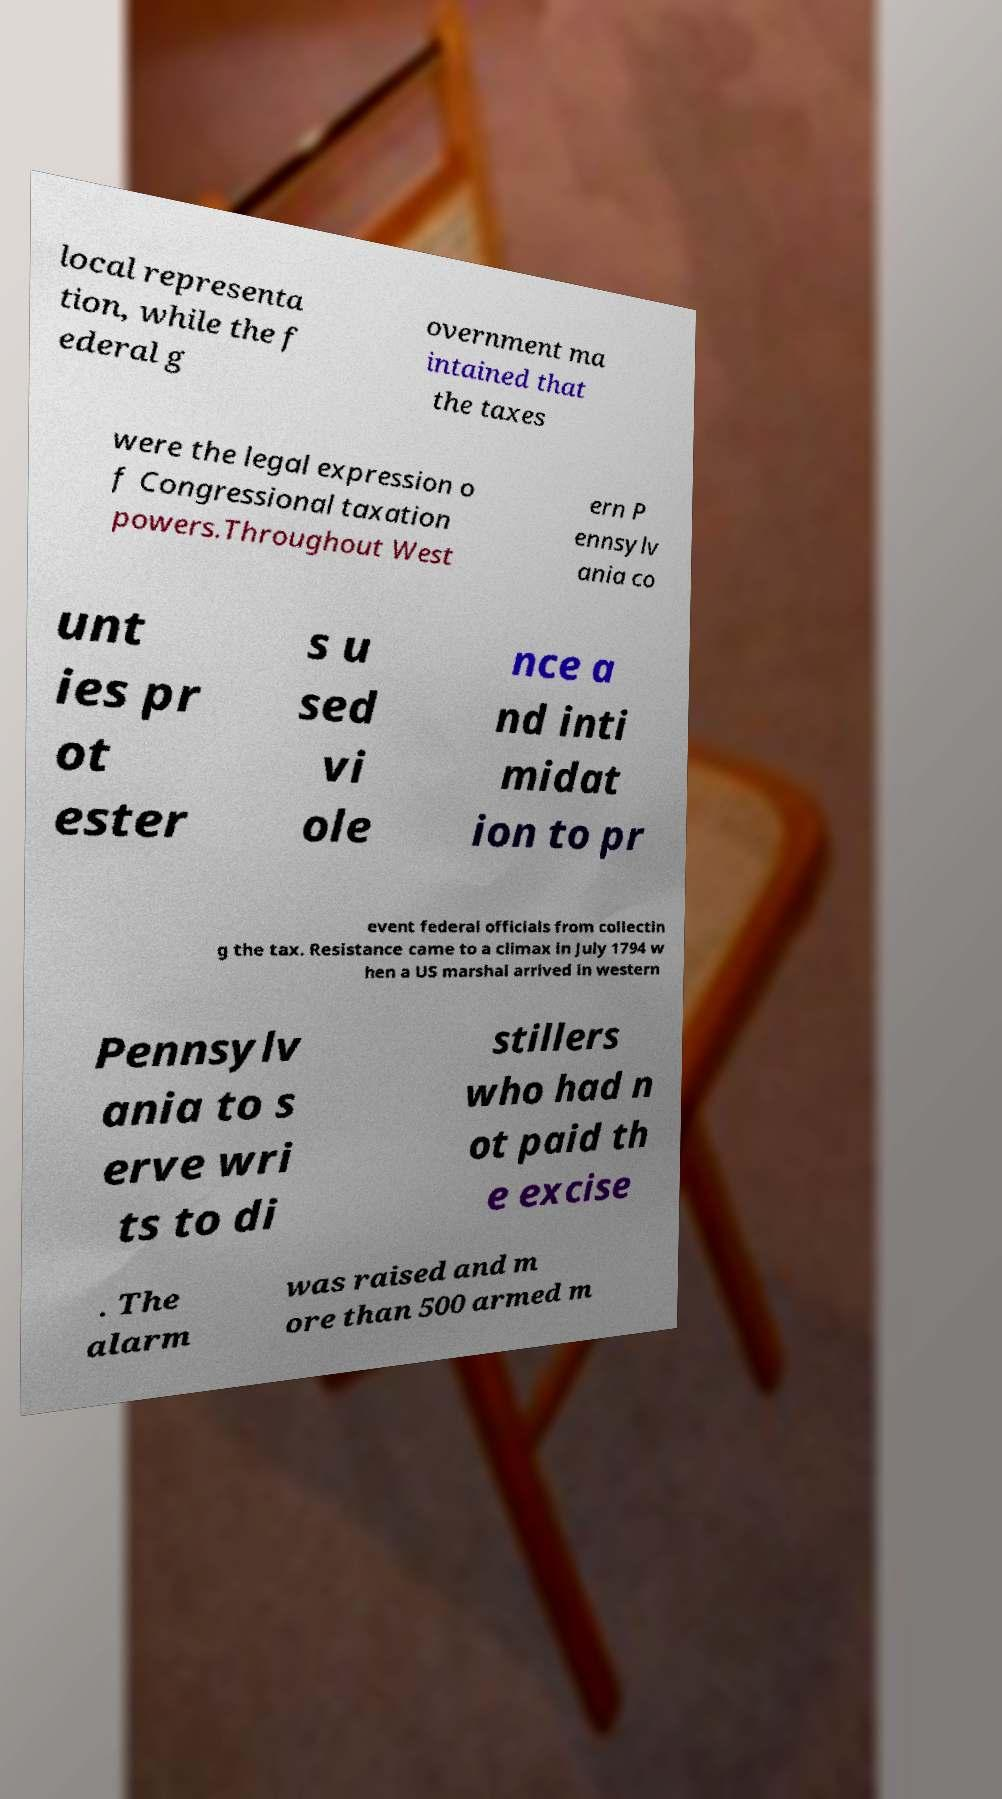For documentation purposes, I need the text within this image transcribed. Could you provide that? local representa tion, while the f ederal g overnment ma intained that the taxes were the legal expression o f Congressional taxation powers.Throughout West ern P ennsylv ania co unt ies pr ot ester s u sed vi ole nce a nd inti midat ion to pr event federal officials from collectin g the tax. Resistance came to a climax in July 1794 w hen a US marshal arrived in western Pennsylv ania to s erve wri ts to di stillers who had n ot paid th e excise . The alarm was raised and m ore than 500 armed m 